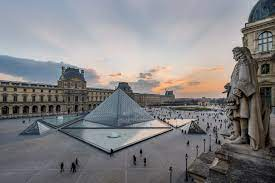What is this photo about? The photo showcases a vibrant scene at the Louvre Museum in Paris, France. Taken from a high vantage point, it provides a panoramic view of the bustling courtyard below. The area is alive with visitors, their colorful outfits adding life to the historical setting. Central to the image is the iconic glass pyramid, designed by architect I.M. Pei, standing in stark contrast to the classical architecture of the surrounding Louvre buildings. Smaller glass pyramids accompany the main structure, all reflecting in the tranquil pool of water, creating symmetrical patterns. The grandeur of the Louvre's classical buildings forms a semicircular embrace around the courtyard, with the museum's prominent dome visible on the right side. Above, a clear blue sky with scattered, wispy clouds caps off this picturesque and lively glimpse of one of the world's most famous landmarks. 